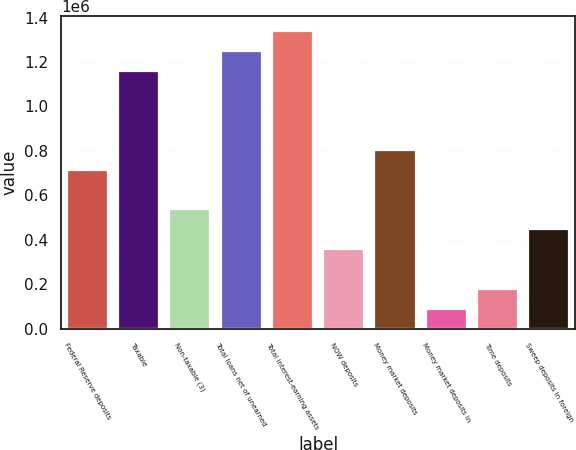<chart> <loc_0><loc_0><loc_500><loc_500><bar_chart><fcel>Federal Reserve deposits<fcel>Taxable<fcel>Non-taxable (3)<fcel>Total loans net of unearned<fcel>Total interest-earning assets<fcel>NOW deposits<fcel>Money market deposits<fcel>Money market deposits in<fcel>Time deposits<fcel>Sweep deposits in foreign<nl><fcel>714885<fcel>1.16169e+06<fcel>536164<fcel>1.25105e+06<fcel>1.34041e+06<fcel>357444<fcel>804245<fcel>89363.2<fcel>178723<fcel>446804<nl></chart> 